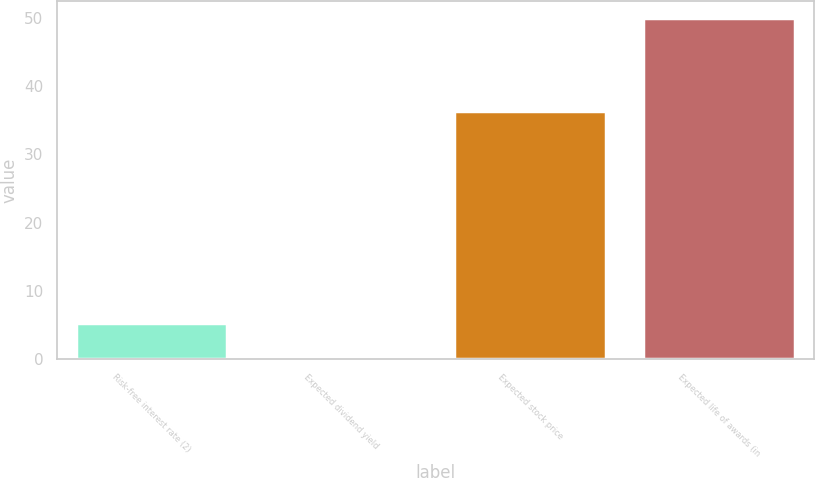Convert chart. <chart><loc_0><loc_0><loc_500><loc_500><bar_chart><fcel>Risk-free interest rate (2)<fcel>Expected dividend yield<fcel>Expected stock price<fcel>Expected life of awards (in<nl><fcel>5.36<fcel>0.4<fcel>36.3<fcel>50<nl></chart> 